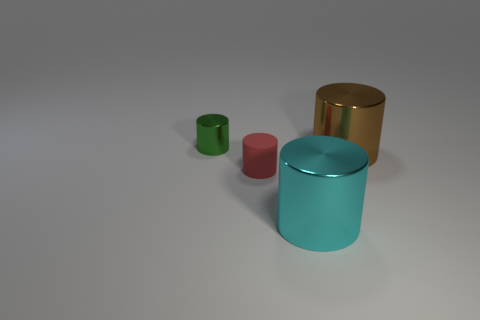Subtract all brown metal cylinders. How many cylinders are left? 3 Add 3 tiny green things. How many objects exist? 7 Subtract all brown cylinders. How many cylinders are left? 3 Subtract all green cylinders. Subtract all purple balls. How many cylinders are left? 3 Subtract all tiny shiny cylinders. Subtract all small yellow rubber things. How many objects are left? 3 Add 2 small red things. How many small red things are left? 3 Add 3 small green metallic cylinders. How many small green metallic cylinders exist? 4 Subtract 0 purple spheres. How many objects are left? 4 